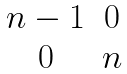Convert formula to latex. <formula><loc_0><loc_0><loc_500><loc_500>\begin{matrix} n - 1 & 0 \\ 0 & n \end{matrix}</formula> 